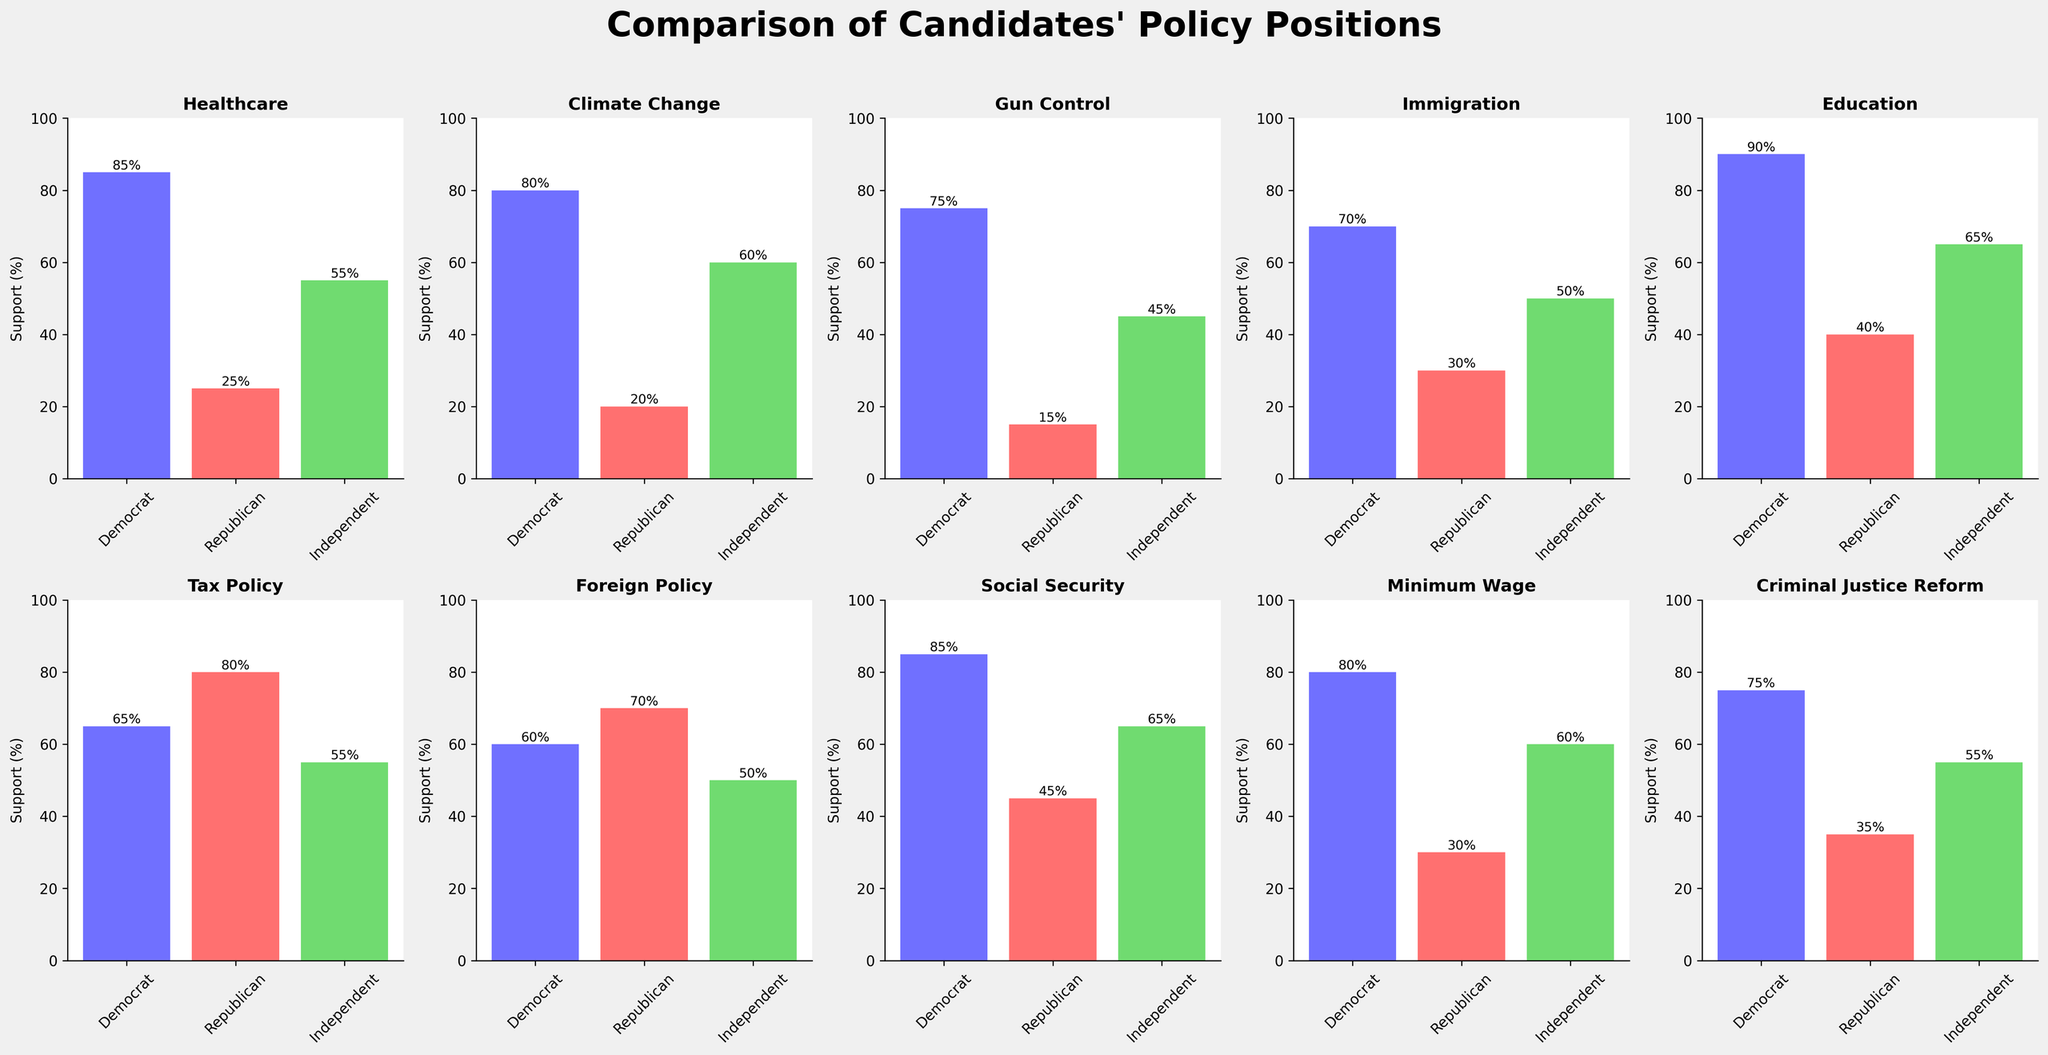What is the highest support for any issue among Democrats? The highest support among Democrats can be found by looking at the bar heights for each issue in the Democrat category. The maximum height is for Education at 90%.
Answer: 90% Which issue has the largest gap in support between Democrats and Republicans? To find the issue with the largest support gap between Democrats and Republicans, calculate the difference for each issue and identify the one with the maximum gap. The largest difference is in Healthcare, with 85% support among Democrats and 25% among Republicans yielding a gap of 60%.
Answer: Healthcare How many issues have at least 50% support among Independents? To answer this, count the issues where the Independent bar reaches or exceeds the 50% mark. They are Healthcare, Climate Change, Immigration, Education, Tax Policy, Social Security, Minimum Wage, and Criminal Justice Reform, totaling 8 issues.
Answer: 8 Which party shows the lowest support for Climate Change? Identify which bar (Democrat, Republican, or Independent) has the lowest height for the Climate Change subplot. The lowest support is from Republicans at 20%.
Answer: Republican What is the average support for Social Security across all three parties? The average is calculated by summing the supports for Social Security (Democrat: 85%, Republican: 45%, Independent: 65%) and dividing by 3. (85 + 45 + 65) / 3 = 195 / 3 = 65.
Answer: 65 Which issue has equal support from Independents and Republicans? Check the heights of bars for each issue to see where the Independent and Republican bars are equal. This occurs in Foreign Policy, both at 50%.
Answer: Foreign Policy List the issues where Republicans have higher support than Democrats. Compare the heights of the bars for each issue. Republicans have higher support than Democrats in Tax Policy and Foreign Policy.
Answer: Tax Policy, Foreign Policy What is the support difference for Gun Control between Democrats and Independents? Subtract the support percentage of Independents from that of Democrats for Gun Control. The difference is 75% - 45% = 30%.
Answer: 30% Which issue has the highest support among Independents? Look for the highest bar in the Independents category across all subplots. The highest support is for Education at 65%.
Answer: Education Identify the issue with the smallest range of support values across the three parties. Calculate the difference between the highest and lowest support values for each issue. The smallest range is for Immigration, with a range of 70% - 30% = 40%.
Answer: Immigration 